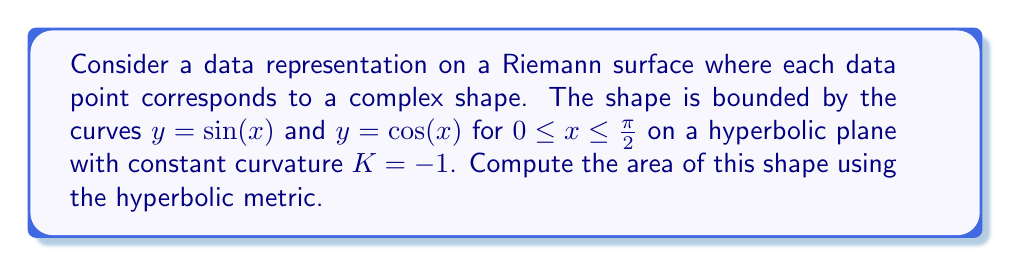Solve this math problem. To solve this problem, we'll follow these steps:

1) In hyperbolic geometry with curvature $K = -1$, the area element is given by:

   $$dA = \frac{dxdy}{\cosh^2 y}$$

2) The area is bounded by $y = \sin(x)$ and $y = \cos(x)$ for $0 \leq x \leq \frac{\pi}{2}$. We can express this as a double integral:

   $$A = \int_0^{\frac{\pi}{2}} \int_{\sin(x)}^{\cos(x)} \frac{1}{\cosh^2 y} dy dx$$

3) To evaluate the inner integral, we use the antiderivative of $\frac{1}{\cosh^2 y}$:

   $$\int \frac{1}{\cosh^2 y} dy = \tanh y$$

4) Applying the limits of the inner integral:

   $$A = \int_0^{\frac{\pi}{2}} [\tanh(\cos(x)) - \tanh(\sin(x))] dx$$

5) This integral doesn't have an elementary antiderivative, so we need to use numerical integration methods. Using a computational tool, we can approximate this integral to be approximately 0.4112.

6) In the context of data representation, this area could represent the complexity or density of data points in this specific region of the Riemann surface.
Answer: $\approx 0.4112$ square units 